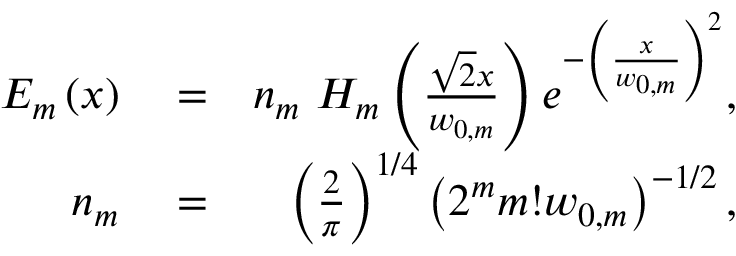Convert formula to latex. <formula><loc_0><loc_0><loc_500><loc_500>\begin{array} { r l r } { E _ { m } \left ( x \right ) } & = } & { n _ { m } H _ { m } \left ( \frac { \sqrt { 2 } x } { w _ { 0 , m } } \right ) e ^ { - \left ( \frac { x } { w _ { 0 , m } } \right ) ^ { 2 } } , } \\ { n _ { m } } & = } & { \left ( \frac { 2 } { \pi } \right ) ^ { 1 / 4 } \left ( 2 ^ { m } m ! w _ { 0 , m } \right ) ^ { - 1 / 2 } , } \end{array}</formula> 